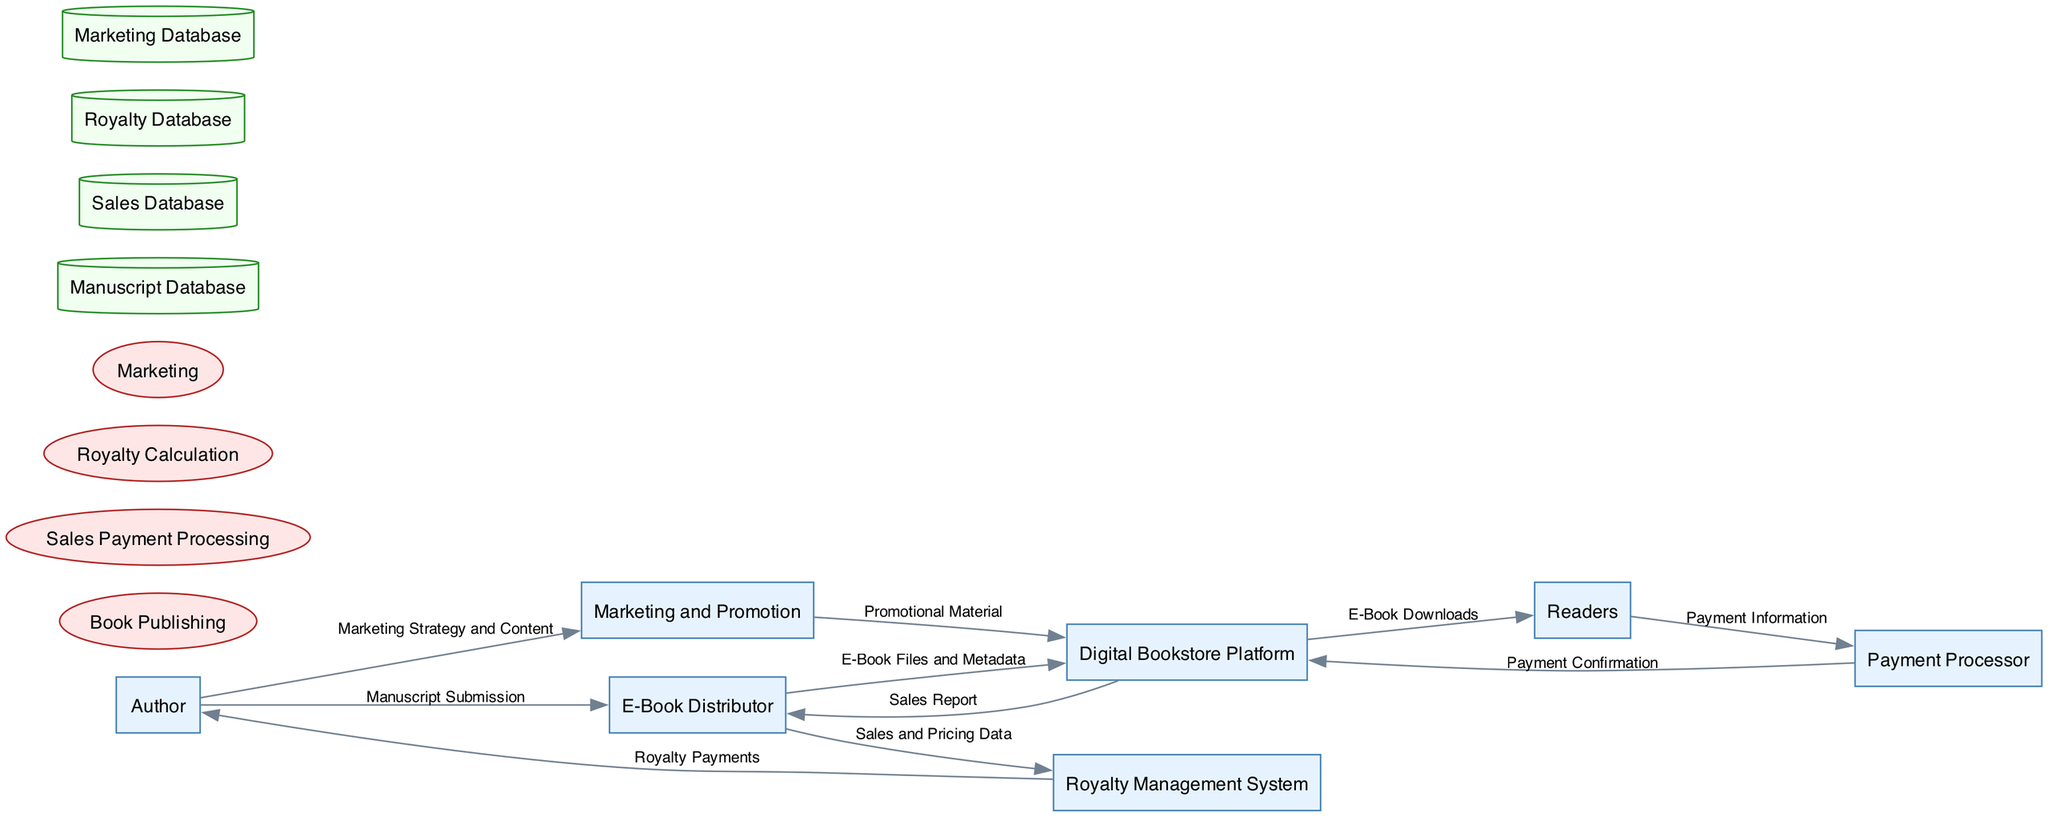What is the main stakeholder in the publishing process? The diagram identifies the "Author" as the main stakeholder in the publishing process, as indicated by the description of the "Author" entity.
Answer: Author How many entities are represented in the diagram? By counting the listed entities in the diagram, five distinct entities can be found: Author, E-Book Distributor, Digital Bookstore Platform, Readers, and Payment Processor.
Answer: Six What type of payments does the Payment Processor handle? The diagram specifies that the Payment Processor deals with "Payment Information" from Readers, indicating the type of data processed.
Answer: Payment Information What does the Royalty Management System deliver to the Author? The Royalty Management System sends "Royalty Payments" to the Author as shown in the data flow, thus highlighting the output of this process.
Answer: Royalty Payments What is the relationship between the E-Book Distributor and the Royalty Management System? The E-Book Distributor shares "Sales and Pricing Data" with the Royalty Management System, indicating a flow of important financial data for royalty calculations.
Answer: Sales and Pricing Data Which entity submits the manuscript? The diagram illustrates that the "Author" is responsible for the submission of the "Manuscript Submission" to the E-Book Distributor, marking the beginning of the publishing process.
Answer: Author Which process is responsible for handling reader payments? The diagram identifies "Sales Payment Processing" as the process that handles payments, as it is listed among the processes depicted.
Answer: Sales Payment Processing How do readers receive e-books from the Digital Bookstore Platform? The flow from the "Digital Bookstore Platform" to "Readers" indicates that "E-Book Downloads" is how readers receive the products following their purchases.
Answer: E-Book Downloads What material does the Marketing and Promotion process send to the Digital Bookstore Platform? It is indicated that the Marketing and Promotion process provides "Promotional Material" to the Digital Bookstore Platform to assist with marketing efforts for e-books.
Answer: Promotional Material 